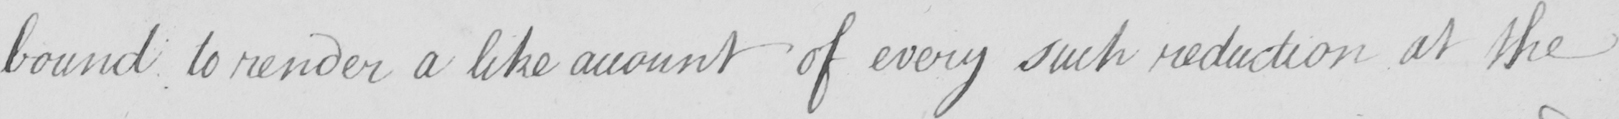Can you read and transcribe this handwriting? bound to render a like amount of every such reduction at the 